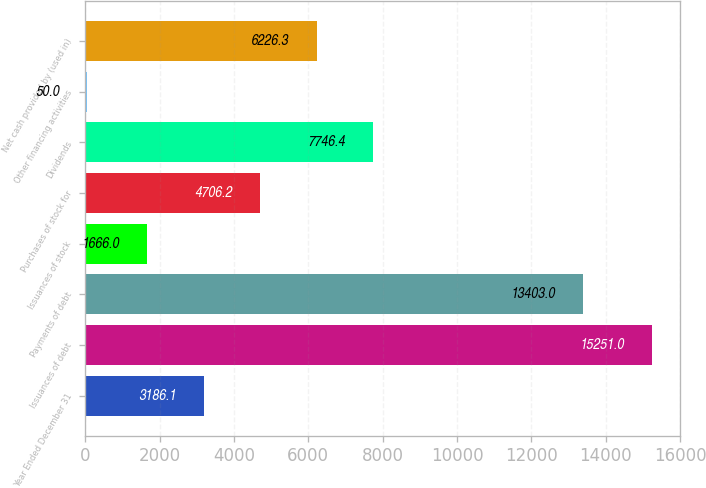Convert chart. <chart><loc_0><loc_0><loc_500><loc_500><bar_chart><fcel>Year Ended December 31<fcel>Issuances of debt<fcel>Payments of debt<fcel>Issuances of stock<fcel>Purchases of stock for<fcel>Dividends<fcel>Other financing activities<fcel>Net cash provided by (used in)<nl><fcel>3186.1<fcel>15251<fcel>13403<fcel>1666<fcel>4706.2<fcel>7746.4<fcel>50<fcel>6226.3<nl></chart> 